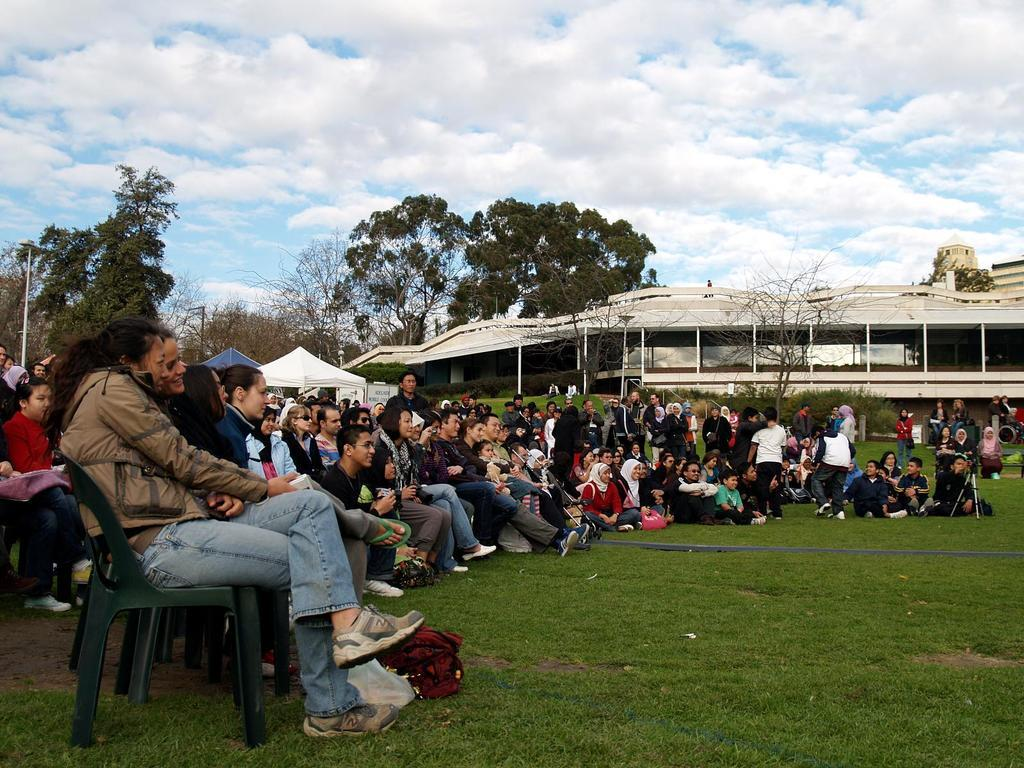What are the people in the image doing? There is a group of persons sitting on the floor in the image. What can be seen in the background of the image? There are trees in the background of the image. How would you describe the sky in the image? The sky is cloudy in the background of the image. What key is used to unlock the door in the image? There is no door or key present in the image; it features a group of persons sitting on the floor with trees and a cloudy sky in the background. 